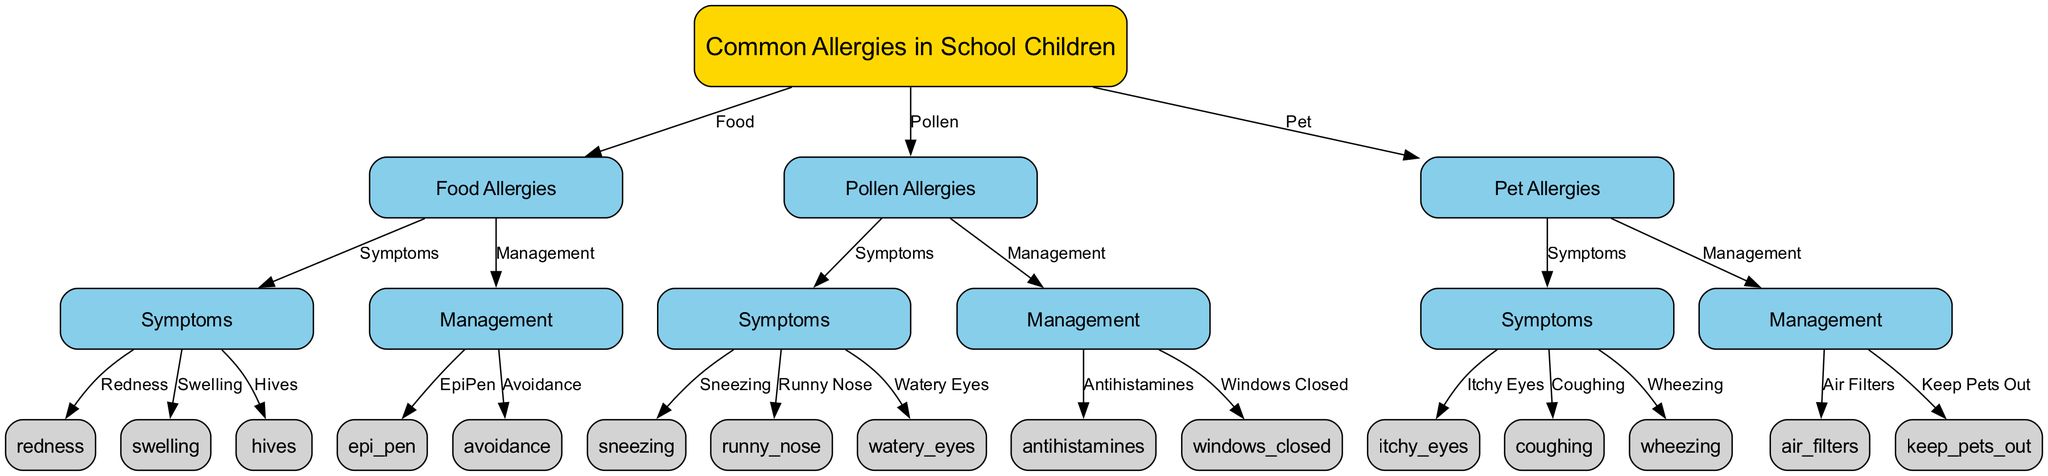What are the three main types of allergies shown in the diagram? The diagram displays three main allergies: Food Allergies, Pollen Allergies, and Pet Allergies. These are clearly indicated as the primary branches stemming from the main node labeled "Common Allergies in School Children."
Answer: Food Allergies, Pollen Allergies, Pet Allergies How many symptoms are listed for food allergies? For food allergies, there are three symptoms listed: Redness, Swelling, and Hives. These are connected directly from the "Symptoms" node under "Food Allergies," showing the specific symptoms associated with food allergies.
Answer: 3 What management strategies are suggested for pollen allergies? The diagram shows two management strategies for pollen allergies: Antihistamines and Windows Closed. These are connected from the "Management" node under "Pollen Allergies," indicating the recommended approaches to managing these allergies.
Answer: Antihistamines, Windows Closed Which symptom is associated with pet allergies? The diagram presents three symptoms related to pet allergies: Itchy Eyes, Coughing, and Wheezing. These symptoms are connected to the "Symptoms" node under "Pet Allergies," indicating their relation to this specific allergy type.
Answer: Itchy Eyes, Coughing, Wheezing What is one management approach for food allergies? One management approach for food allergies is the use of an EpiPen. This is established by looking at the "Management" node for food allergies and noting the connection to the EpiPen node as a vital management strategy.
Answer: EpiPen 